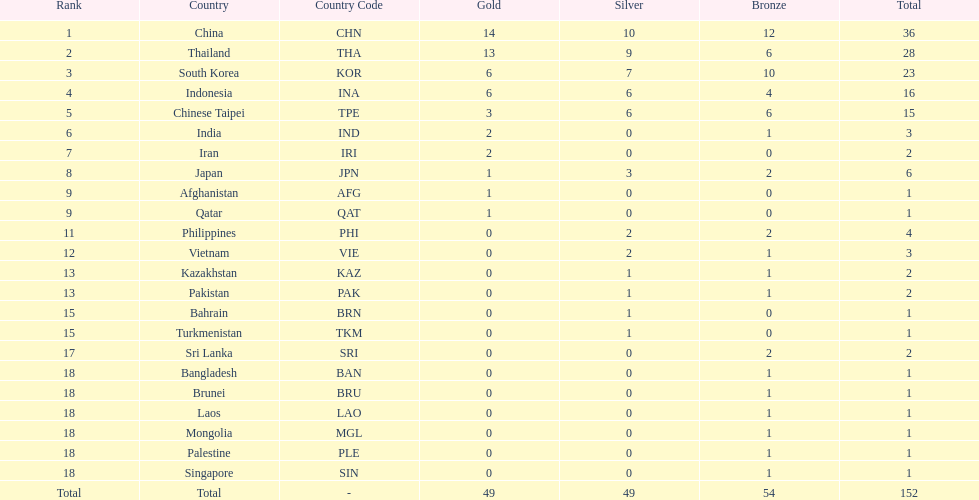What was the number of medals earned by indonesia (ina) ? 16. 